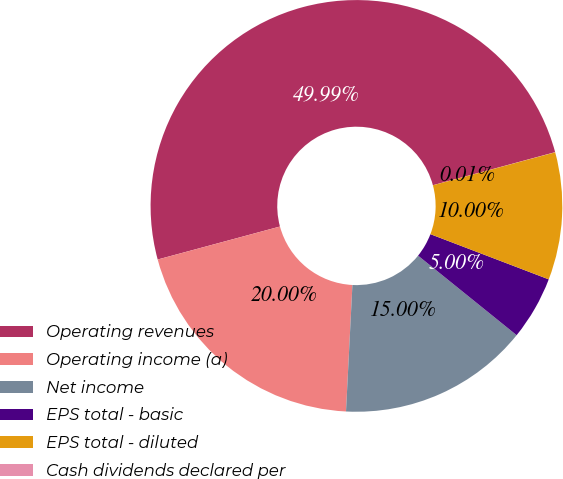<chart> <loc_0><loc_0><loc_500><loc_500><pie_chart><fcel>Operating revenues<fcel>Operating income (a)<fcel>Net income<fcel>EPS total - basic<fcel>EPS total - diluted<fcel>Cash dividends declared per<nl><fcel>49.99%<fcel>20.0%<fcel>15.0%<fcel>5.0%<fcel>10.0%<fcel>0.01%<nl></chart> 